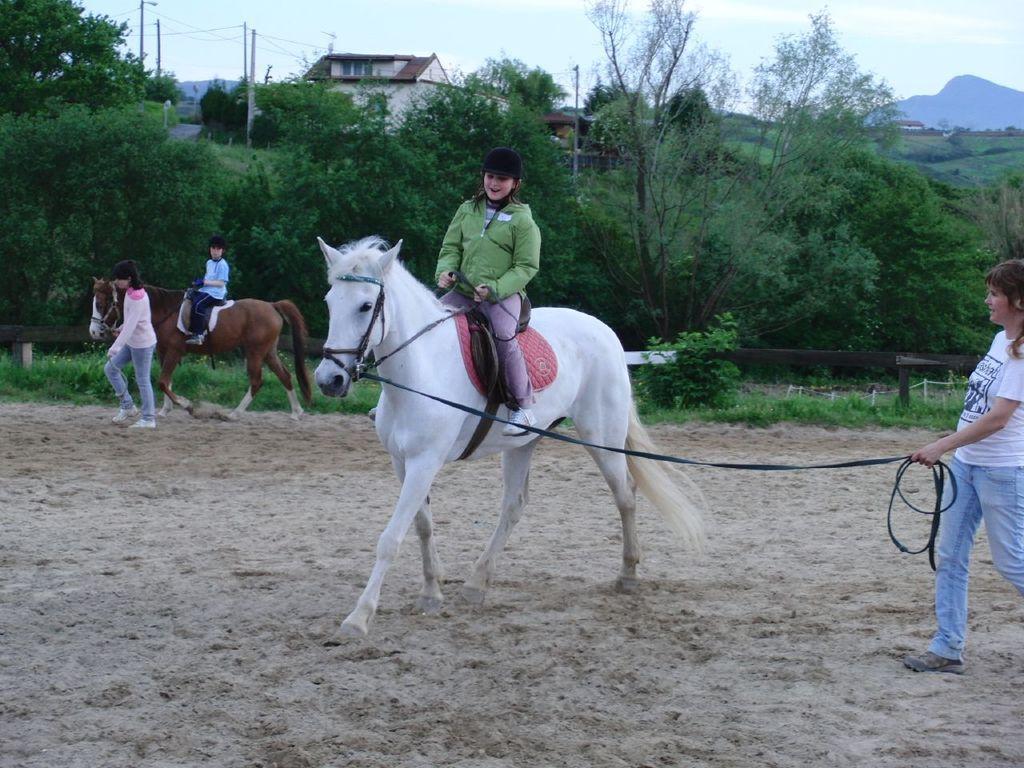Could you give a brief overview of what you see in this image? There are two kids sitting on two different horses and there are two persons holding a belt which is tightened to the horses and there are trees and a building in the background. 